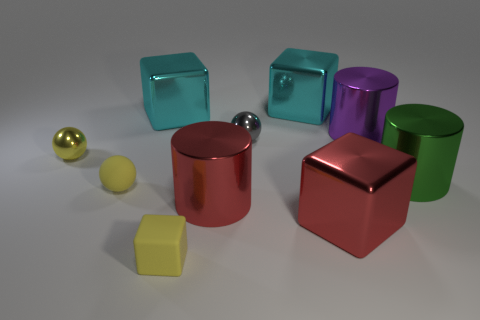Subtract all brown spheres. How many cyan blocks are left? 2 Subtract all shiny balls. How many balls are left? 1 Subtract 1 cylinders. How many cylinders are left? 2 Subtract all red cubes. How many cubes are left? 3 Subtract all purple cubes. Subtract all brown balls. How many cubes are left? 4 Subtract all purple metal things. Subtract all yellow matte things. How many objects are left? 7 Add 5 large red metal cylinders. How many large red metal cylinders are left? 6 Add 1 blue objects. How many blue objects exist? 1 Subtract 0 yellow cylinders. How many objects are left? 10 Subtract all spheres. How many objects are left? 7 